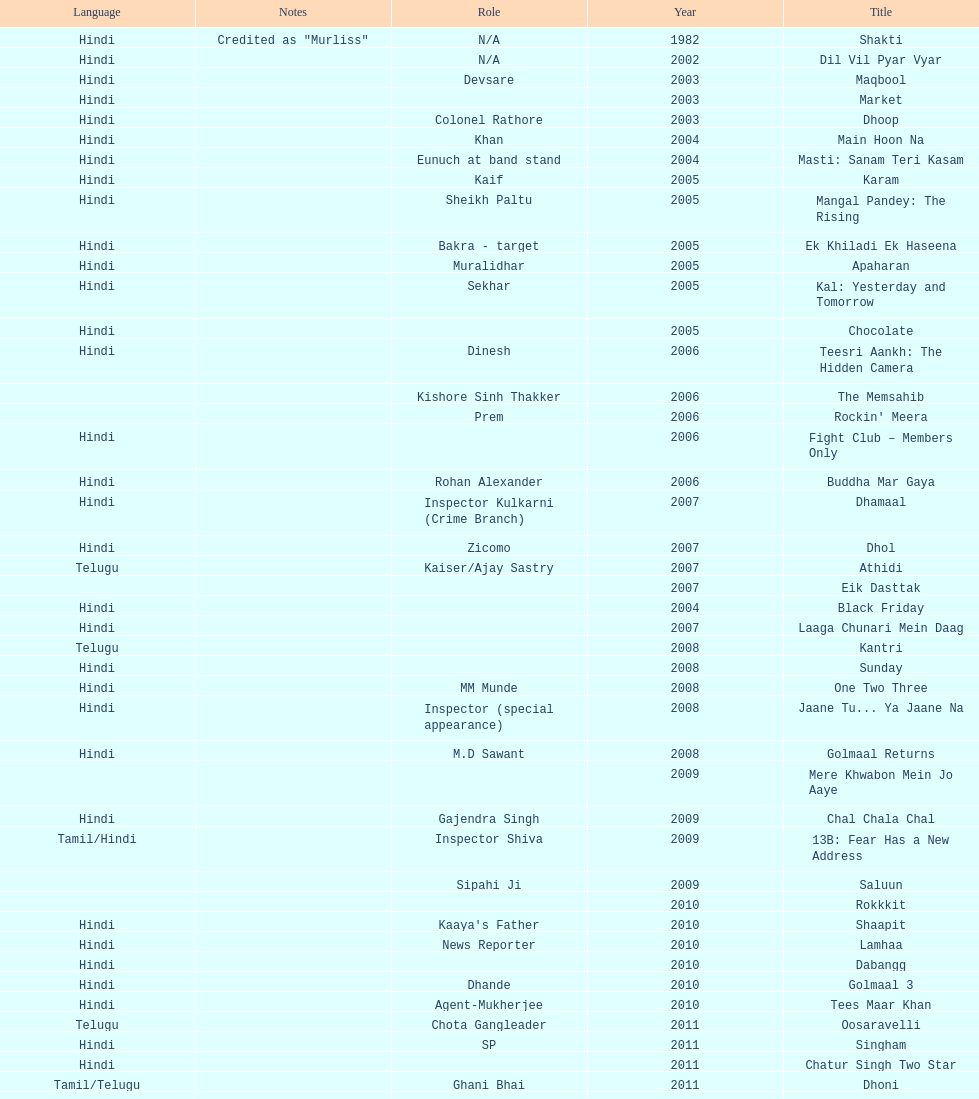Could you parse the entire table as a dict? {'header': ['Language', 'Notes', 'Role', 'Year', 'Title'], 'rows': [['Hindi', 'Credited as "Murliss"', 'N/A', '1982', 'Shakti'], ['Hindi', '', 'N/A', '2002', 'Dil Vil Pyar Vyar'], ['Hindi', '', 'Devsare', '2003', 'Maqbool'], ['Hindi', '', '', '2003', 'Market'], ['Hindi', '', 'Colonel Rathore', '2003', 'Dhoop'], ['Hindi', '', 'Khan', '2004', 'Main Hoon Na'], ['Hindi', '', 'Eunuch at band stand', '2004', 'Masti: Sanam Teri Kasam'], ['Hindi', '', 'Kaif', '2005', 'Karam'], ['Hindi', '', 'Sheikh Paltu', '2005', 'Mangal Pandey: The Rising'], ['Hindi', '', 'Bakra - target', '2005', 'Ek Khiladi Ek Haseena'], ['Hindi', '', 'Muralidhar', '2005', 'Apaharan'], ['Hindi', '', 'Sekhar', '2005', 'Kal: Yesterday and Tomorrow'], ['Hindi', '', '', '2005', 'Chocolate'], ['Hindi', '', 'Dinesh', '2006', 'Teesri Aankh: The Hidden Camera'], ['', '', 'Kishore Sinh Thakker', '2006', 'The Memsahib'], ['', '', 'Prem', '2006', "Rockin' Meera"], ['Hindi', '', '', '2006', 'Fight Club – Members Only'], ['Hindi', '', 'Rohan Alexander', '2006', 'Buddha Mar Gaya'], ['Hindi', '', 'Inspector Kulkarni (Crime Branch)', '2007', 'Dhamaal'], ['Hindi', '', 'Zicomo', '2007', 'Dhol'], ['Telugu', '', 'Kaiser/Ajay Sastry', '2007', 'Athidi'], ['', '', '', '2007', 'Eik Dasttak'], ['Hindi', '', '', '2004', 'Black Friday'], ['Hindi', '', '', '2007', 'Laaga Chunari Mein Daag'], ['Telugu', '', '', '2008', 'Kantri'], ['Hindi', '', '', '2008', 'Sunday'], ['Hindi', '', 'MM Munde', '2008', 'One Two Three'], ['Hindi', '', 'Inspector (special appearance)', '2008', 'Jaane Tu... Ya Jaane Na'], ['Hindi', '', 'M.D Sawant', '2008', 'Golmaal Returns'], ['', '', '', '2009', 'Mere Khwabon Mein Jo Aaye'], ['Hindi', '', 'Gajendra Singh', '2009', 'Chal Chala Chal'], ['Tamil/Hindi', '', 'Inspector Shiva', '2009', '13B: Fear Has a New Address'], ['', '', 'Sipahi Ji', '2009', 'Saluun'], ['', '', '', '2010', 'Rokkkit'], ['Hindi', '', "Kaaya's Father", '2010', 'Shaapit'], ['Hindi', '', 'News Reporter', '2010', 'Lamhaa'], ['Hindi', '', '', '2010', 'Dabangg'], ['Hindi', '', 'Dhande', '2010', 'Golmaal 3'], ['Hindi', '', 'Agent-Mukherjee', '2010', 'Tees Maar Khan'], ['Telugu', '', 'Chota Gangleader', '2011', 'Oosaravelli'], ['Hindi', '', 'SP', '2011', 'Singham'], ['Hindi', '', '', '2011', 'Chatur Singh Two Star'], ['Tamil/Telugu', '', 'Ghani Bhai', '2011', 'Dhoni'], ['Telugu', '', 'Kidnapper', '2012', 'Mr. Nookayya'], ['Hindi', '', 'Naxalite', '2012', 'Aalaap'], ['Hindi', '', 'Tejeshwar Singh', '2012', 'Choron Ki Baraat'], ['Hindi', '', 'Hanumant Singh', '2012', 'Jeena Hai Toh Thok Daal'], ['Hindi', '', '', '2012', 'OMG: Oh My God!'], ['Hindi', '', '', '2012', 'Chakravyuh'], ['Telugu', '', 'Chakravarthi', '2012', 'Krishnam Vande Jagadgurum'], ['Malayalam', '', '', '2012', 'Karma Yodha'], ['Hindi', '', '', '2013', 'Hungame pe Hungama'], ['Telugu', '', '', '2013', 'Platform No. 6'], ['Tamil', '', 'Marudhamuthu', '2013', 'Pattathu Yaanai'], ['Hindi', '', '', '2013', 'Zindagi 50-50'], ['Telugu', '', 'Durani', '2013', 'Yevadu'], ['Telugu', '', '', '2013', 'Karmachari']]} What is the first language after hindi Telugu. 